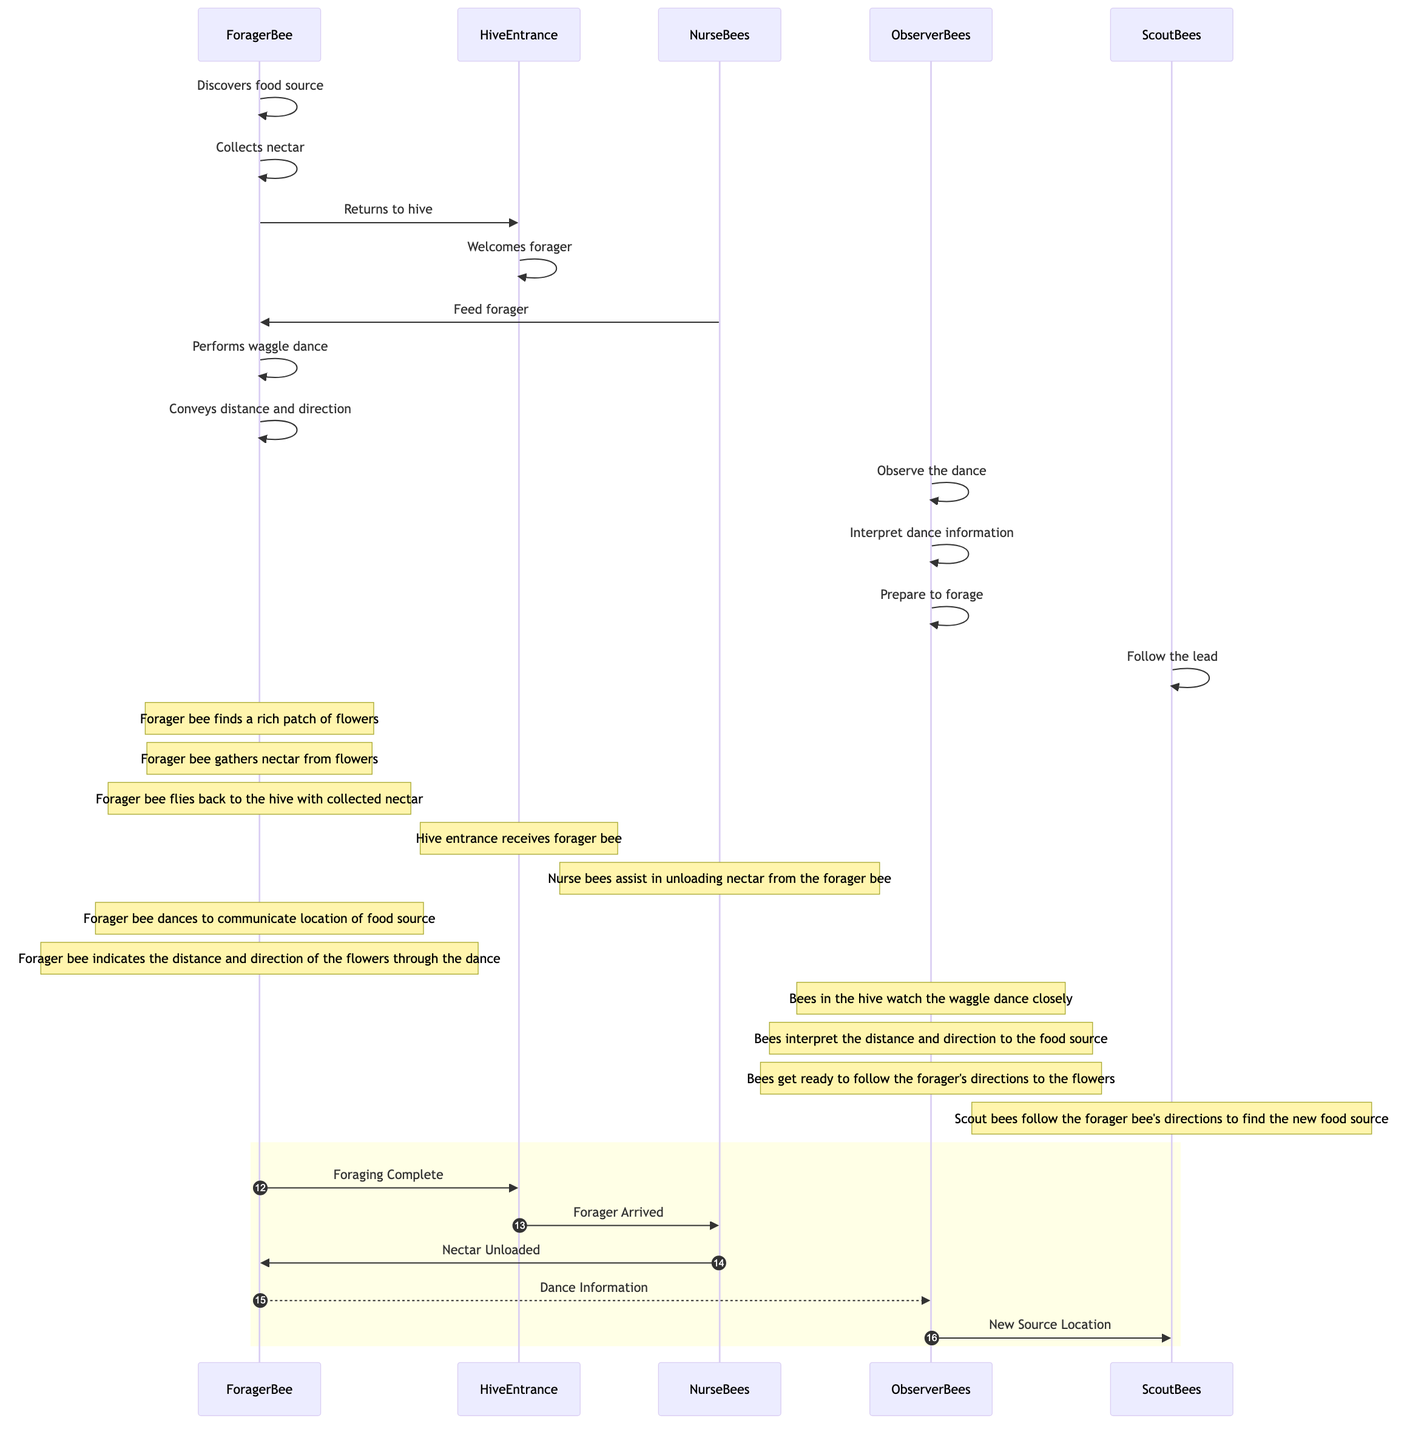What does the forager bee discover first? The sequence diagram indicates that the forager bee starts its actions by discovering the food source. This is the first action performed by the ForagerBee participant in the diagram.
Answer: food source How many actions are performed by the ForagerBee? By checking the actions recorded under the ForagerBee participant, a total of four actions can be identified: discovers food source, collects nectar, returns to hive, and performs waggle dance. Therefore, we count these actions for our answer.
Answer: four Which participant assists in unloading nectar? The sequence diagram clearly shows that the NurseBees participant is the one that assists the forager bee in unloading nectar, as specified in their recorded action.
Answer: NurseBees What type of dance does the ForagerBee perform? According to the diagram, the action performed by the ForagerBee that conveys direction and distance to other bees is referred to as the "waggle dance." This terminology directly comes from the ForagerBee's action described in the diagram.
Answer: waggle dance What do the ObserverBees do after observing the dance? The diagram specifies that after observing the dance, the ObserverBees interpret the information conveyed by the dance and then prepare to forage. Therefore, following the observation, interpreting the dance information is the key subsequent action.
Answer: interpret dance information What do ScoutBees do in the sequence? ScoutBees' action is outlined as following the lead indicated by the forager bee. Their role comes after the ObserverBees have prepared to forage based on the danced information relayed by the ForagerBee.
Answer: Follow the lead How many participants are there in the diagram? By counting the unique participants specified in the diagram: ForagerBee, HiveEntrance, NurseBees, ObserverBees, and ScoutBees, we find that there are a total of five distinct participants involved in this communication sequence.
Answer: five What indicates the completion of foraging in the diagram? The diagram describes a specific action labeled "Foraging Complete," which represents that the process of foraging has wrapped up successfully and is a central concluding action for the forager bee.
Answer: Foraging Complete What action immediately follows the forager returning to the hive? The sequence follows a clear linear pattern, where after the forager returns to the hive, the next action that occurs is the hive entrance welcoming the forager bee. This is a sequential action representing the interaction upon arrival.
Answer: Welcomes forager What do NurseBees do after welcoming the forager? Following the welcoming action from the HiveEntrance, NurseBees assist in feeding the forager bee by unloading the collected nectar. This process immediately follows their welcome role, indicating a supportive action towards the forager bee.
Answer: Feed forager 